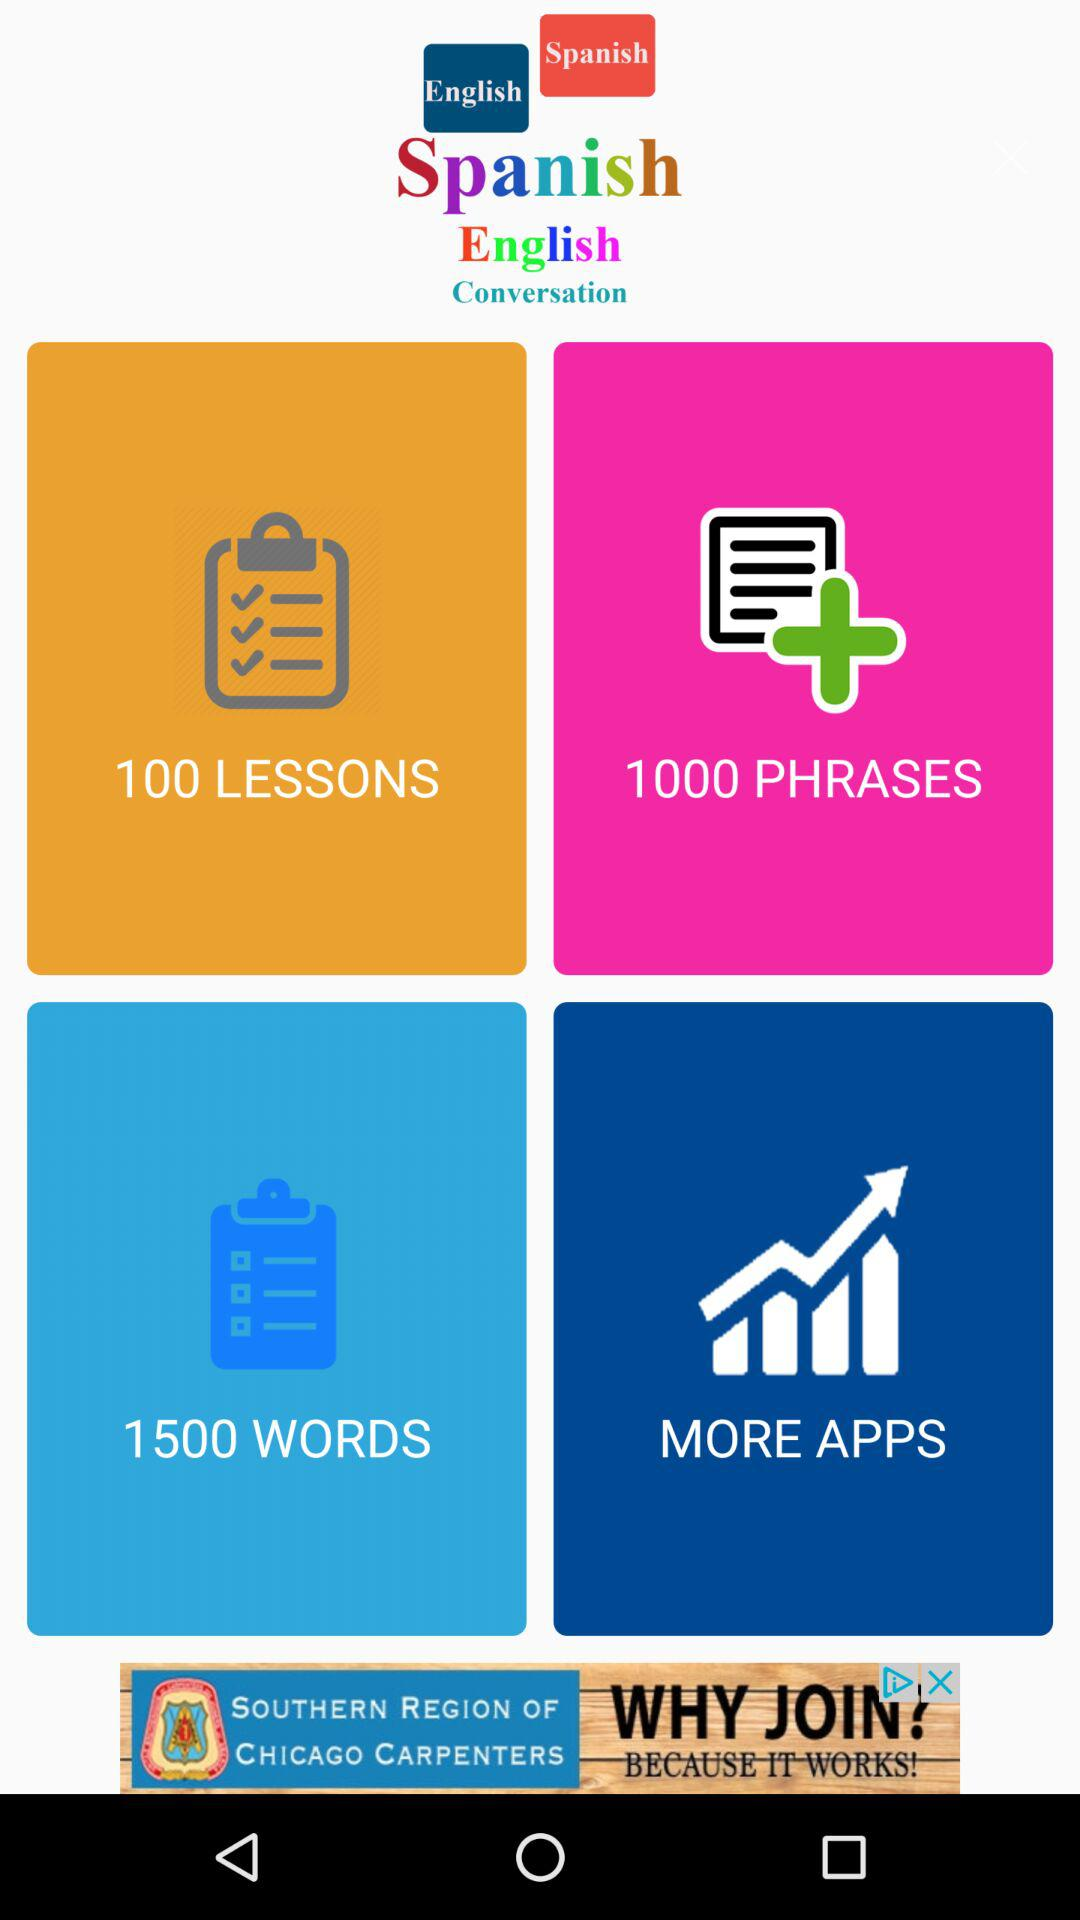How many phrases are there? There are 1000 phrases. 